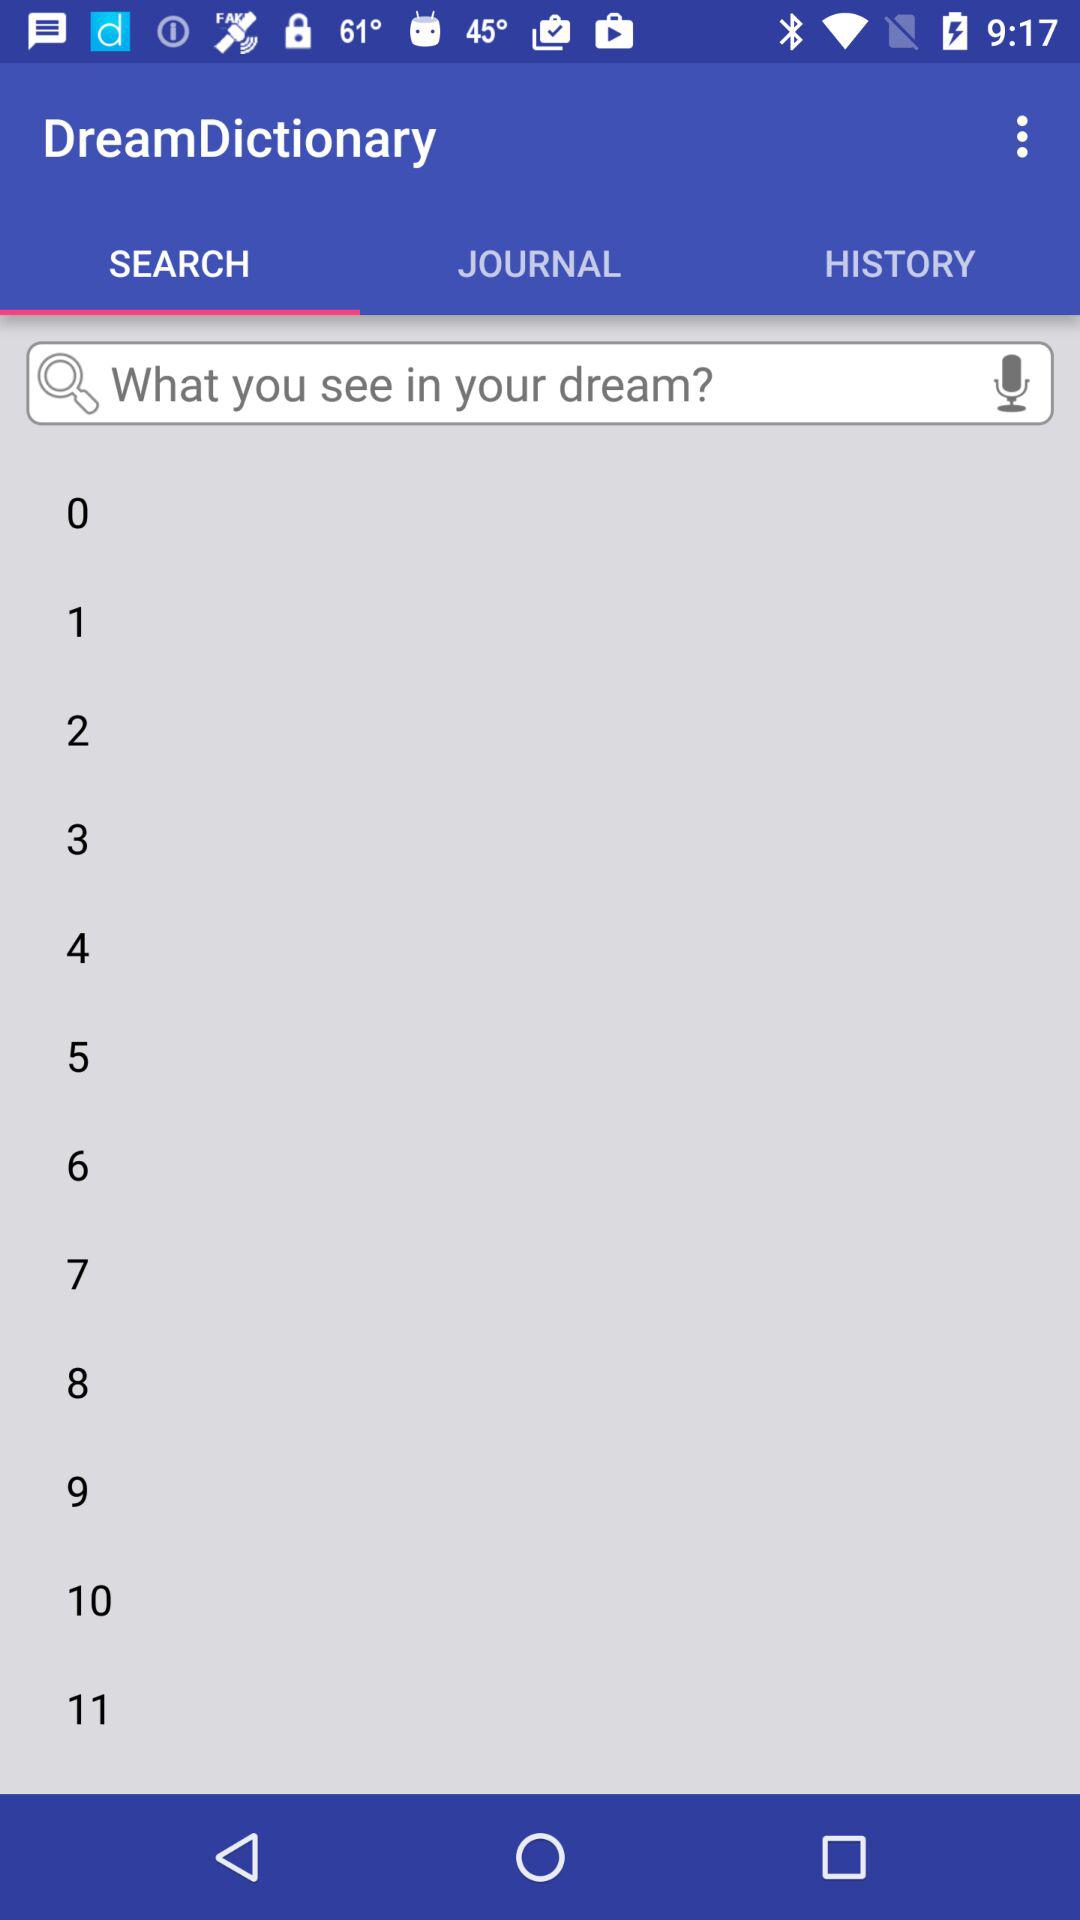Which option is selected? The selected option is "SEARCH". 